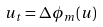<formula> <loc_0><loc_0><loc_500><loc_500>u _ { t } = \Delta \phi _ { m } ( u )</formula> 